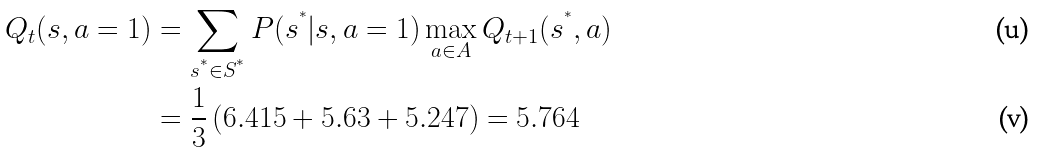<formula> <loc_0><loc_0><loc_500><loc_500>Q _ { t } ( s , a = 1 ) & = \sum _ { s ^ { ^ { * } } \in S ^ { ^ { * } } } P ( s ^ { ^ { * } } | s , a = 1 ) \max _ { a \in A } Q _ { t + 1 } ( s ^ { ^ { * } } , a ) \\ & = \frac { 1 } { 3 } \left ( 6 . 4 1 5 + 5 . 6 3 + 5 . 2 4 7 \right ) = 5 . 7 6 4</formula> 